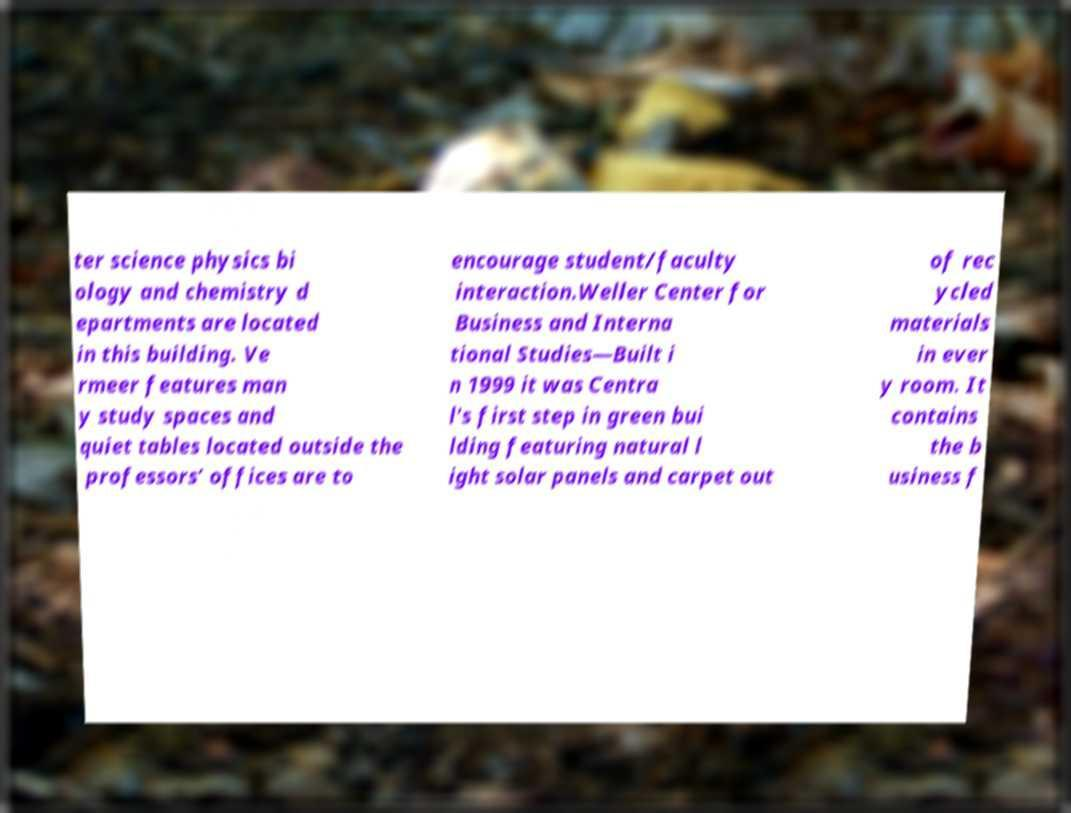Please identify and transcribe the text found in this image. ter science physics bi ology and chemistry d epartments are located in this building. Ve rmeer features man y study spaces and quiet tables located outside the professors’ offices are to encourage student/faculty interaction.Weller Center for Business and Interna tional Studies—Built i n 1999 it was Centra l's first step in green bui lding featuring natural l ight solar panels and carpet out of rec ycled materials in ever y room. It contains the b usiness f 